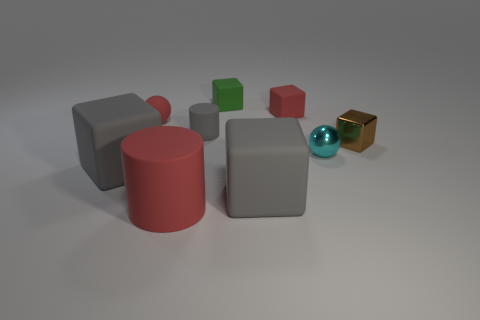Are there an equal number of rubber cylinders that are on the left side of the red rubber sphere and green cubes behind the big matte cylinder?
Your answer should be compact. No. Does the small object that is behind the red matte block have the same material as the small ball that is to the right of the small red matte sphere?
Make the answer very short. No. What material is the tiny brown thing?
Ensure brevity in your answer.  Metal. How many other objects are the same color as the rubber ball?
Make the answer very short. 2. Is the metallic sphere the same color as the matte ball?
Give a very brief answer. No. What number of purple rubber blocks are there?
Offer a terse response. 0. What material is the red object in front of the object to the right of the small cyan metal ball made of?
Provide a short and direct response. Rubber. What is the material of the brown object that is the same size as the green cube?
Offer a terse response. Metal. There is a gray matte cube left of the red rubber cylinder; is it the same size as the small gray rubber object?
Provide a succinct answer. No. There is a big gray rubber object left of the large red rubber thing; is its shape the same as the cyan thing?
Keep it short and to the point. No. 